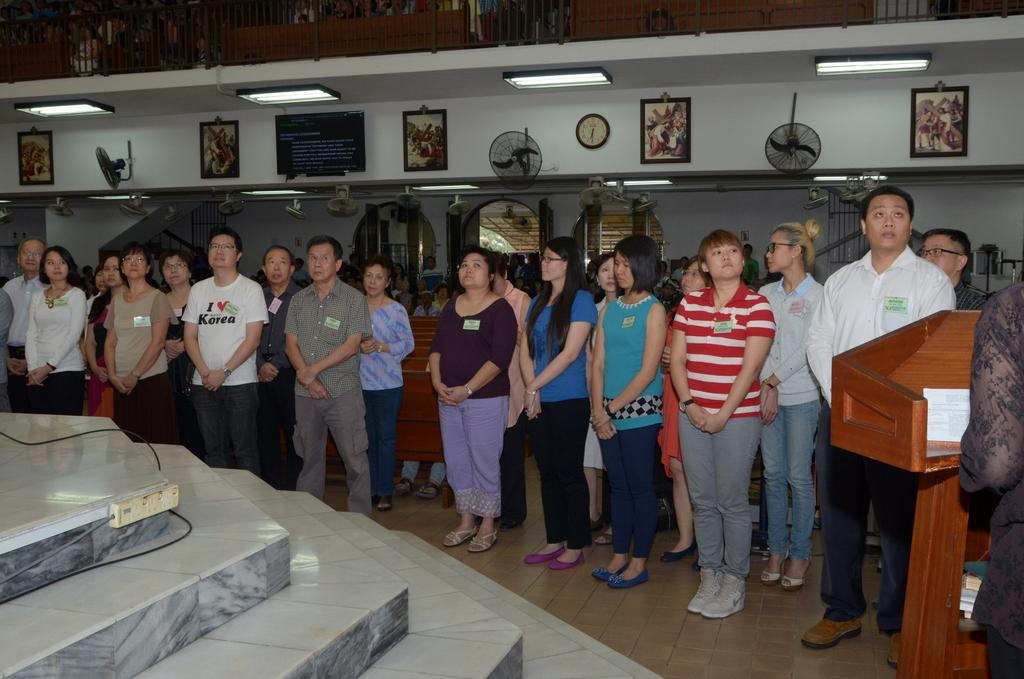What types of people are present in the image? There are men and women standing in the image. What can be seen on the wall in the image? There are photo frames on the wall. What time-keeping device is visible in the image? There is a clock in the image. What appliance is present in the image to provide air circulation? There is a fan in the image. What type of lighting is present in the image? There are lights in the image. What architectural feature is present in the image that allows for movement between different levels? There are stairs in the image. What type of wool is being spun by the society in the image? There is no wool or society present in the image; it features people, photo frames, a clock, a fan, lights, and stairs. 